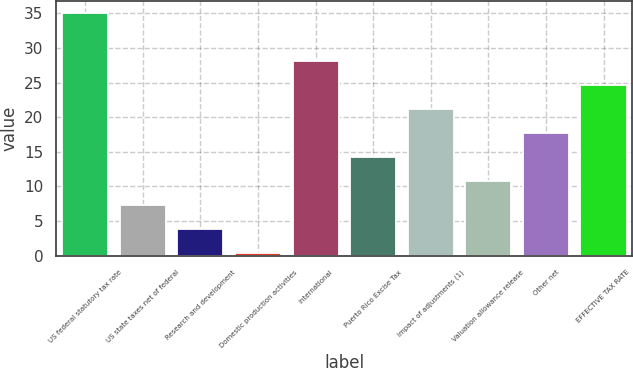Convert chart. <chart><loc_0><loc_0><loc_500><loc_500><bar_chart><fcel>US federal statutory tax rate<fcel>US state taxes net of federal<fcel>Research and development<fcel>Domestic production activities<fcel>International<fcel>Puerto Rico Excise Tax<fcel>Impact of adjustments (1)<fcel>Valuation allowance release<fcel>Other net<fcel>EFFECTIVE TAX RATE<nl><fcel>35<fcel>7.32<fcel>3.86<fcel>0.4<fcel>28.08<fcel>14.24<fcel>21.16<fcel>10.78<fcel>17.7<fcel>24.62<nl></chart> 